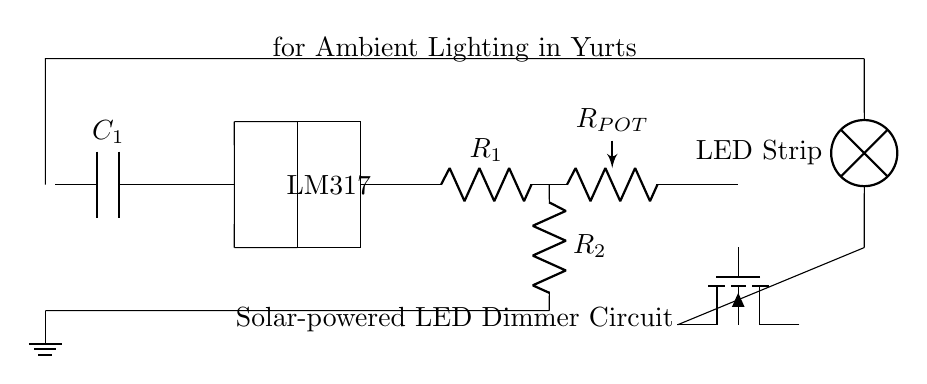What component is used to regulate voltage in this circuit? The component used to regulate voltage is the LM317, which is placed in the middle of the circuit and specifically designed for voltage regulation.
Answer: LM317 What type of light source is used in this circuit? The light source used in this circuit is an LED strip, indicated by the component labeled "LED Strip" in the diagram.
Answer: LED Strip What does the potentiometer do in this circuit? The potentiometer allows for adjustable resistance, which can be used to control the brightness of the LED strip by varying the current flowing through the strip.
Answer: Adjustable resistance How many resistors are present in this circuit? There are two resistors present in the circuit, labeled R1 and R2, which are involved in determining the output voltage of the LM317 regulator.
Answer: Two What type of transistor is used in this circuit? The transistor used in this circuit is an n-channel MOSFET, identified in the diagram by the symbol labeled as "nfet."
Answer: n-channel MOSFET How is the solar panel connected in the circuit? The solar panel is connected at the beginning of the circuit, supplying power to the capacitor and subsequent components, forming the initial power source for the entire circuit.
Answer: At the beginning What is the purpose of the capacitor in this circuit? The capacitor smooths out the voltage fluctuations from the solar panel, providing a stable voltage supply to the voltage regulator and ensuring consistent performance of the LED strip.
Answer: Smooths voltage fluctuations 